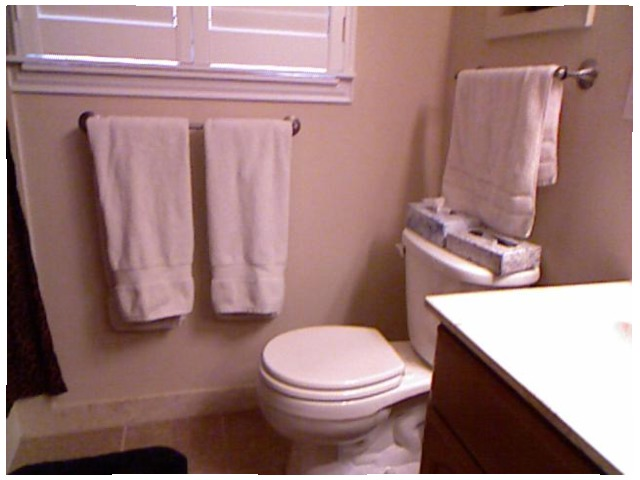<image>
Can you confirm if the towel is under the sink? No. The towel is not positioned under the sink. The vertical relationship between these objects is different. Is the window above the cloth? Yes. The window is positioned above the cloth in the vertical space, higher up in the scene. 